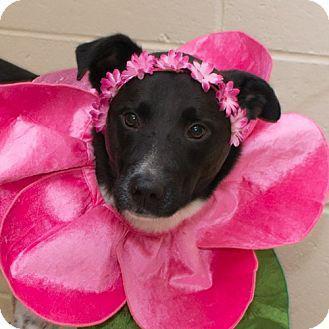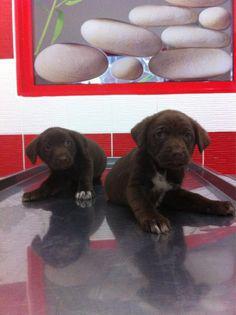The first image is the image on the left, the second image is the image on the right. Evaluate the accuracy of this statement regarding the images: "a human is posing with a brown lab". Is it true? Answer yes or no. No. The first image is the image on the left, the second image is the image on the right. For the images displayed, is the sentence "There is one human and one dog in the right image." factually correct? Answer yes or no. No. 